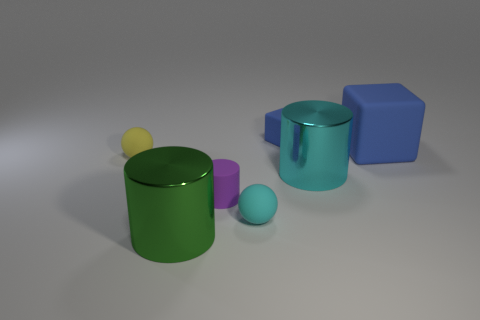There is another rubber thing that is the same shape as the tiny cyan rubber thing; what is its color? The rubber object that shares the same spherical shape as the smaller cyan one is yellow in color. 